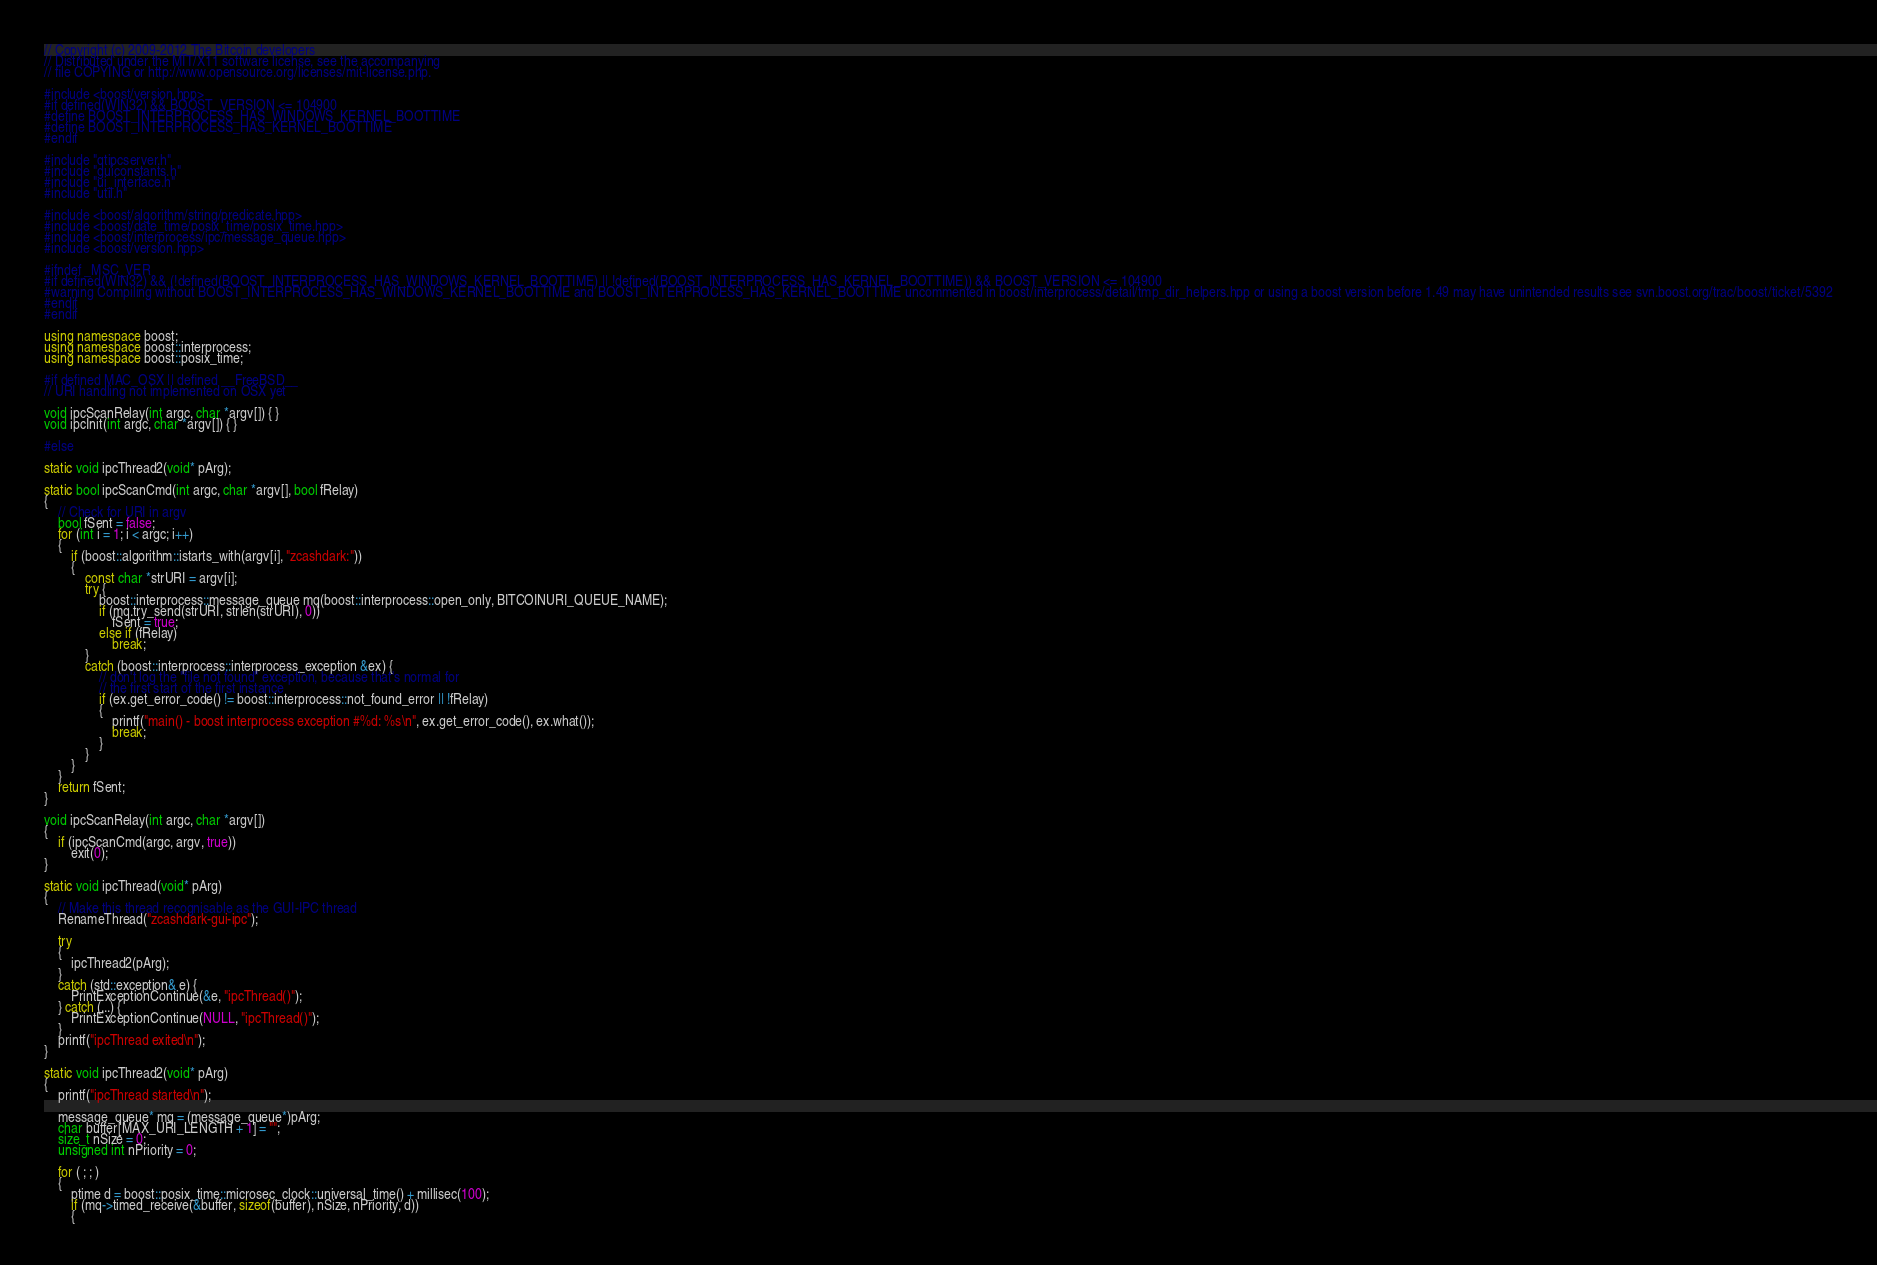Convert code to text. <code><loc_0><loc_0><loc_500><loc_500><_C++_>// Copyright (c) 2009-2012 The Bitcoin developers
// Distributed under the MIT/X11 software license, see the accompanying
// file COPYING or http://www.opensource.org/licenses/mit-license.php.

#include <boost/version.hpp>
#if defined(WIN32) && BOOST_VERSION <= 104900
#define BOOST_INTERPROCESS_HAS_WINDOWS_KERNEL_BOOTTIME
#define BOOST_INTERPROCESS_HAS_KERNEL_BOOTTIME
#endif

#include "qtipcserver.h"
#include "guiconstants.h"
#include "ui_interface.h"
#include "util.h"

#include <boost/algorithm/string/predicate.hpp>
#include <boost/date_time/posix_time/posix_time.hpp>
#include <boost/interprocess/ipc/message_queue.hpp>
#include <boost/version.hpp>

#ifndef _MSC_VER
#if defined(WIN32) && (!defined(BOOST_INTERPROCESS_HAS_WINDOWS_KERNEL_BOOTTIME) || !defined(BOOST_INTERPROCESS_HAS_KERNEL_BOOTTIME)) && BOOST_VERSION <= 104900
#warning Compiling without BOOST_INTERPROCESS_HAS_WINDOWS_KERNEL_BOOTTIME and BOOST_INTERPROCESS_HAS_KERNEL_BOOTTIME uncommented in boost/interprocess/detail/tmp_dir_helpers.hpp or using a boost version before 1.49 may have unintended results see svn.boost.org/trac/boost/ticket/5392
#endif
#endif

using namespace boost;
using namespace boost::interprocess;
using namespace boost::posix_time;

#if defined MAC_OSX || defined __FreeBSD__
// URI handling not implemented on OSX yet

void ipcScanRelay(int argc, char *argv[]) { }
void ipcInit(int argc, char *argv[]) { }

#else

static void ipcThread2(void* pArg);

static bool ipcScanCmd(int argc, char *argv[], bool fRelay)
{
    // Check for URI in argv
    bool fSent = false;
    for (int i = 1; i < argc; i++)
    {
        if (boost::algorithm::istarts_with(argv[i], "zcashdark:"))
        {
            const char *strURI = argv[i];
            try {
                boost::interprocess::message_queue mq(boost::interprocess::open_only, BITCOINURI_QUEUE_NAME);
                if (mq.try_send(strURI, strlen(strURI), 0))
                    fSent = true;
                else if (fRelay)
                    break;
            }
            catch (boost::interprocess::interprocess_exception &ex) {
                // don't log the "file not found" exception, because that's normal for
                // the first start of the first instance
                if (ex.get_error_code() != boost::interprocess::not_found_error || !fRelay)
                {
                    printf("main() - boost interprocess exception #%d: %s\n", ex.get_error_code(), ex.what());
                    break;
                }
            }
        }
    }
    return fSent;
}

void ipcScanRelay(int argc, char *argv[])
{
    if (ipcScanCmd(argc, argv, true))
        exit(0);
}

static void ipcThread(void* pArg)
{
    // Make this thread recognisable as the GUI-IPC thread
    RenameThread("zcashdark-gui-ipc");
	
    try
    {
        ipcThread2(pArg);
    }
    catch (std::exception& e) {
        PrintExceptionContinue(&e, "ipcThread()");
    } catch (...) {
        PrintExceptionContinue(NULL, "ipcThread()");
    }
    printf("ipcThread exited\n");
}

static void ipcThread2(void* pArg)
{
    printf("ipcThread started\n");

    message_queue* mq = (message_queue*)pArg;
    char buffer[MAX_URI_LENGTH + 1] = "";
    size_t nSize = 0;
    unsigned int nPriority = 0;

    for ( ; ; )
    {
        ptime d = boost::posix_time::microsec_clock::universal_time() + millisec(100);
        if (mq->timed_receive(&buffer, sizeof(buffer), nSize, nPriority, d))
        {</code> 